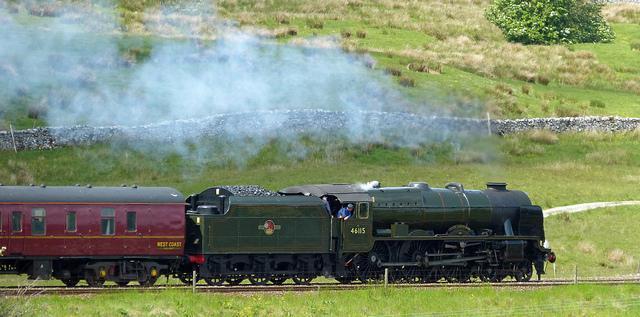How many chairs are on the right side of the tree?
Give a very brief answer. 0. 